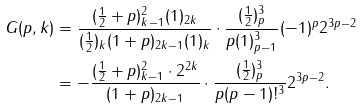<formula> <loc_0><loc_0><loc_500><loc_500>G ( p , k ) & = \frac { ( \frac { 1 } { 2 } + p ) _ { k - 1 } ^ { 2 } ( 1 ) _ { 2 k } } { ( \frac { 1 } { 2 } ) _ { k } ( 1 + p ) _ { 2 k - 1 } ( 1 ) _ { k } } \cdot \frac { ( \frac { 1 } { 2 } ) _ { p } ^ { 3 } } { p ( 1 ) _ { p - 1 } ^ { 3 } } ( - 1 ) ^ { p } 2 ^ { 3 p - 2 } \\ & = - \frac { ( \frac { 1 } { 2 } + p ) _ { k - 1 } ^ { 2 } \cdot 2 ^ { 2 k } } { ( 1 + p ) _ { 2 k - 1 } } \cdot \frac { ( \frac { 1 } { 2 } ) _ { p } ^ { 3 } } { p ( p - 1 ) ! ^ { 3 } } 2 ^ { 3 p - 2 } .</formula> 